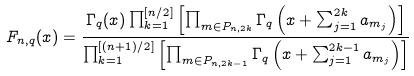<formula> <loc_0><loc_0><loc_500><loc_500>F _ { n , q } ( x ) = \frac { \Gamma _ { q } ( x ) \prod _ { k = 1 } ^ { [ n / 2 ] } \left [ \prod _ { m \in P _ { n , 2 k } } \Gamma _ { q } \left ( x + \sum _ { j = 1 } ^ { 2 k } a _ { m _ { j } } \right ) \right ] } { \prod _ { k = 1 } ^ { [ ( n + 1 ) / 2 ] } \left [ \prod _ { m \in P _ { n , 2 k - 1 } } \Gamma _ { q } \left ( x + \sum _ { j = 1 } ^ { 2 k - 1 } a _ { m _ { j } } \right ) \right ] }</formula> 